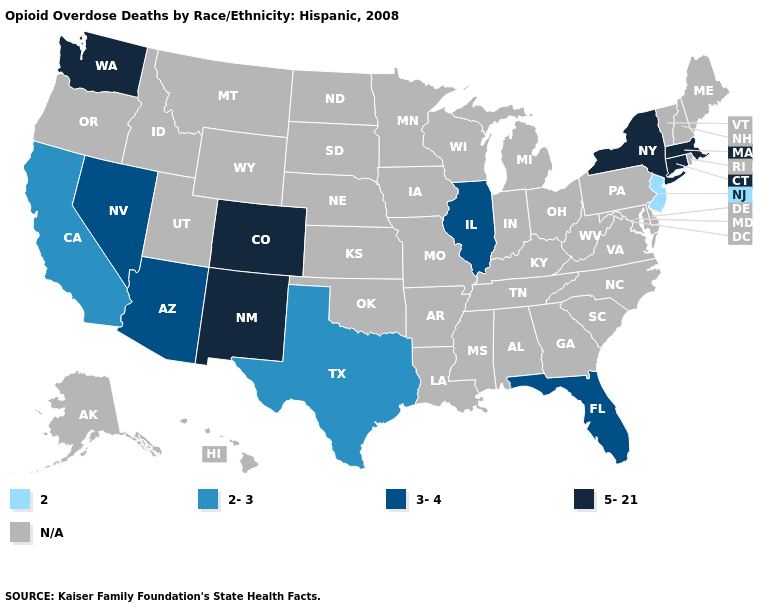What is the value of Pennsylvania?
Quick response, please. N/A. Does the map have missing data?
Quick response, please. Yes. What is the value of Alaska?
Give a very brief answer. N/A. Among the states that border Colorado , does Arizona have the highest value?
Keep it brief. No. What is the value of Illinois?
Write a very short answer. 3-4. Name the states that have a value in the range 2-3?
Concise answer only. California, Texas. Which states have the highest value in the USA?
Be succinct. Colorado, Connecticut, Massachusetts, New Mexico, New York, Washington. Which states have the highest value in the USA?
Keep it brief. Colorado, Connecticut, Massachusetts, New Mexico, New York, Washington. What is the highest value in the West ?
Give a very brief answer. 5-21. Does New York have the lowest value in the USA?
Be succinct. No. Is the legend a continuous bar?
Concise answer only. No. Which states have the lowest value in the West?
Give a very brief answer. California. Name the states that have a value in the range N/A?
Give a very brief answer. Alabama, Alaska, Arkansas, Delaware, Georgia, Hawaii, Idaho, Indiana, Iowa, Kansas, Kentucky, Louisiana, Maine, Maryland, Michigan, Minnesota, Mississippi, Missouri, Montana, Nebraska, New Hampshire, North Carolina, North Dakota, Ohio, Oklahoma, Oregon, Pennsylvania, Rhode Island, South Carolina, South Dakota, Tennessee, Utah, Vermont, Virginia, West Virginia, Wisconsin, Wyoming. 